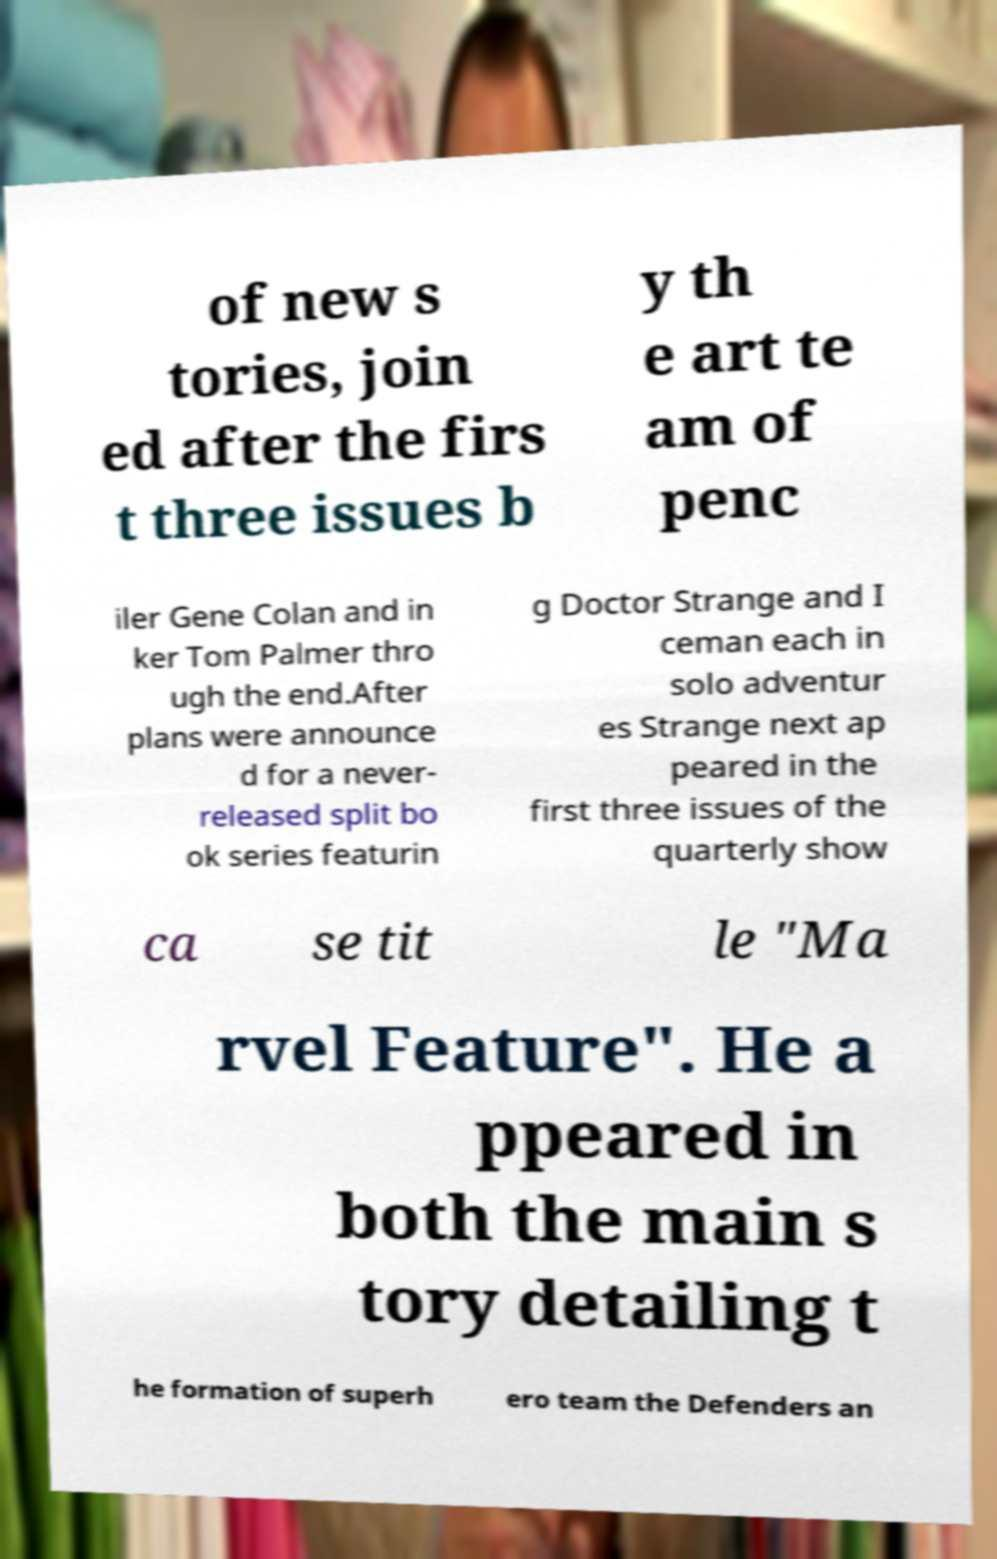Can you accurately transcribe the text from the provided image for me? of new s tories, join ed after the firs t three issues b y th e art te am of penc iler Gene Colan and in ker Tom Palmer thro ugh the end.After plans were announce d for a never- released split bo ok series featurin g Doctor Strange and I ceman each in solo adventur es Strange next ap peared in the first three issues of the quarterly show ca se tit le "Ma rvel Feature". He a ppeared in both the main s tory detailing t he formation of superh ero team the Defenders an 